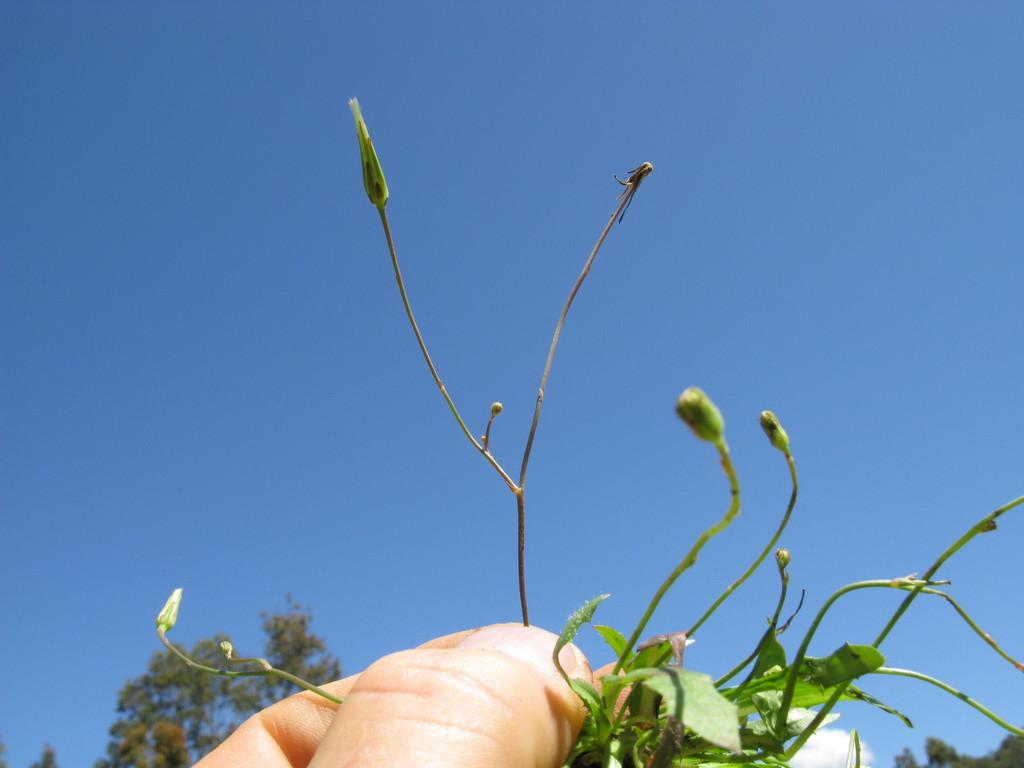What is the person in the image holding? The person is holding leaves in the image. What can be seen in the background of the image? There are trees visible in the background of the image. What is the condition of the top of the person's head in the image? There is no information provided about the condition of the person's head or any specific part of their body in the image. 